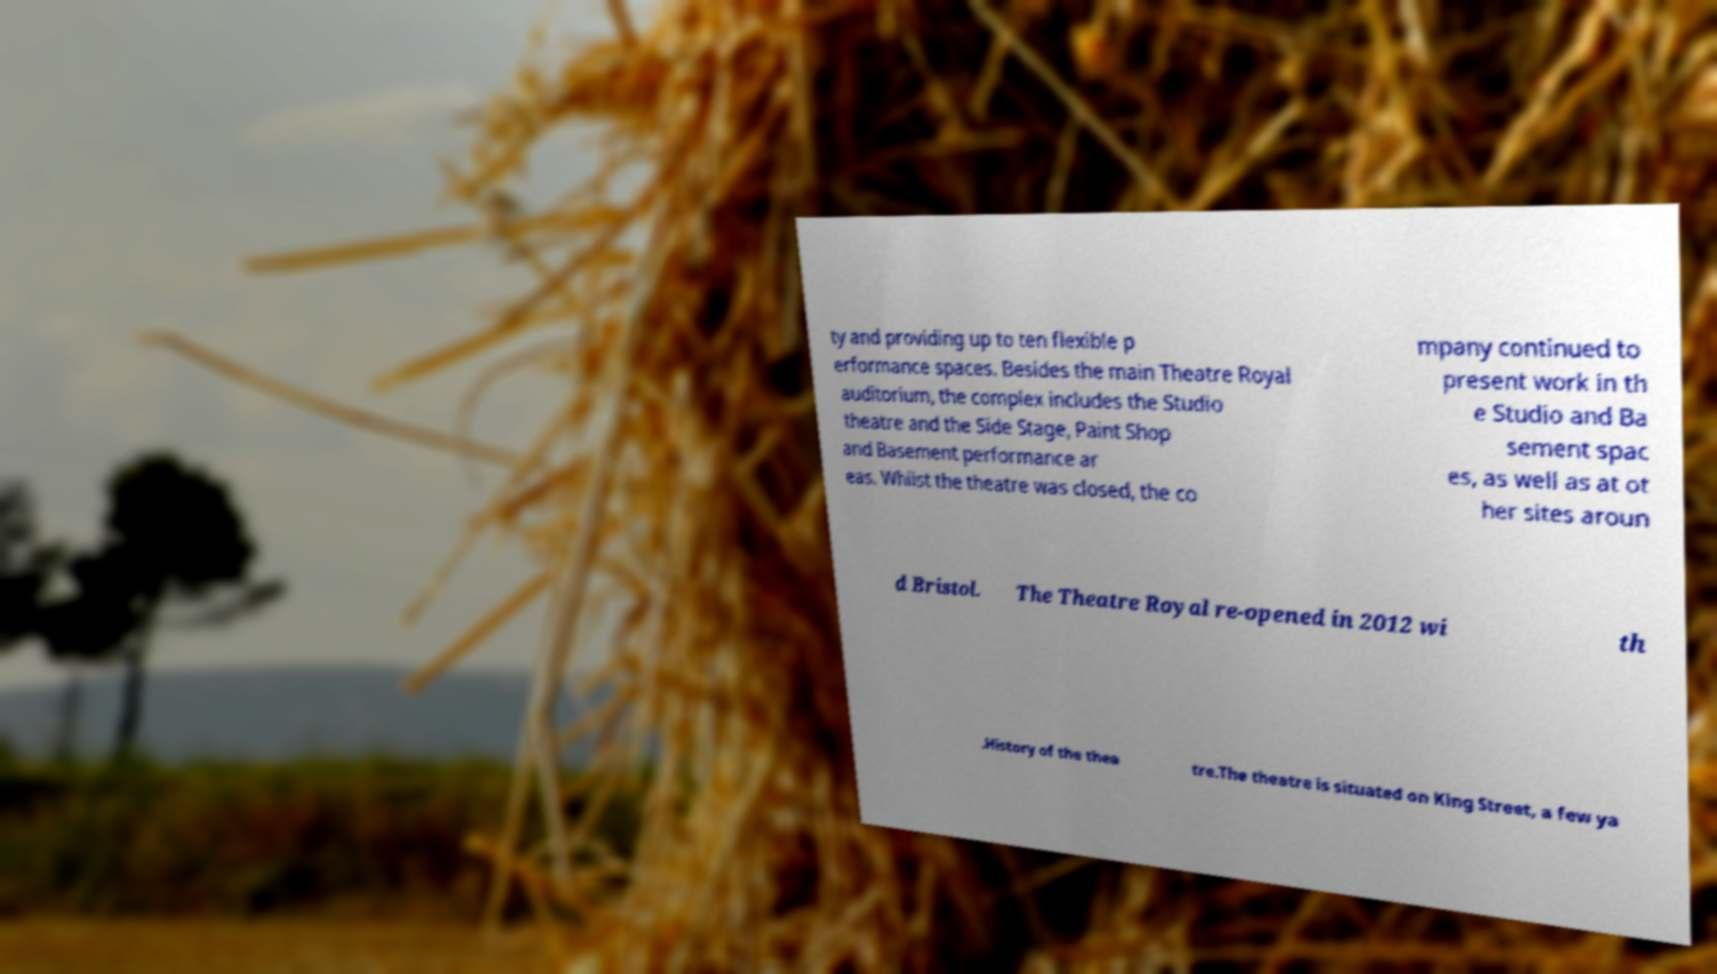Could you assist in decoding the text presented in this image and type it out clearly? ty and providing up to ten flexible p erformance spaces. Besides the main Theatre Royal auditorium, the complex includes the Studio theatre and the Side Stage, Paint Shop and Basement performance ar eas. Whilst the theatre was closed, the co mpany continued to present work in th e Studio and Ba sement spac es, as well as at ot her sites aroun d Bristol. The Theatre Royal re-opened in 2012 wi th .History of the thea tre.The theatre is situated on King Street, a few ya 